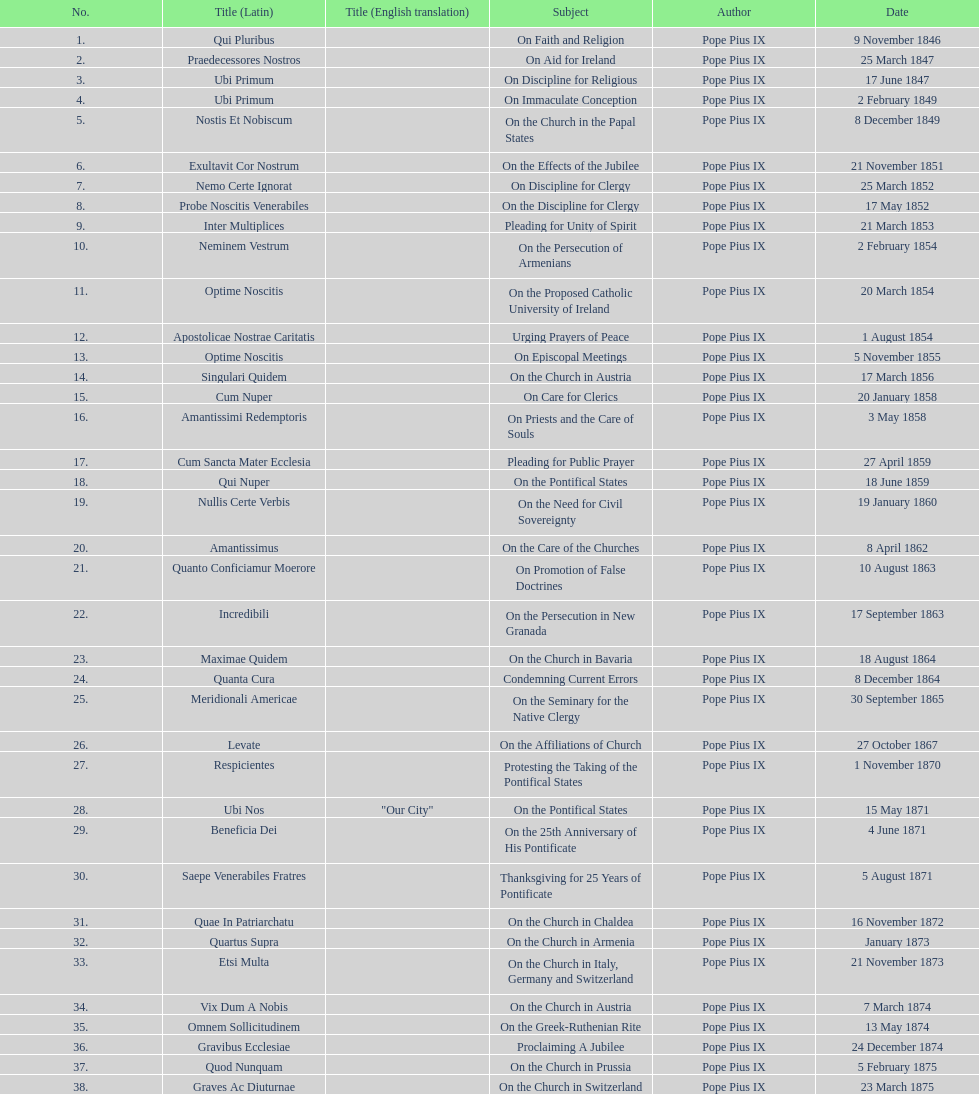What is the previous subject after on the effects of the jubilee? On the Church in the Papal States. Parse the full table. {'header': ['No.', 'Title (Latin)', 'Title (English translation)', 'Subject', 'Author', 'Date'], 'rows': [['1.', 'Qui Pluribus', '', 'On Faith and Religion', 'Pope Pius IX', '9 November 1846'], ['2.', 'Praedecessores Nostros', '', 'On Aid for Ireland', 'Pope Pius IX', '25 March 1847'], ['3.', 'Ubi Primum', '', 'On Discipline for Religious', 'Pope Pius IX', '17 June 1847'], ['4.', 'Ubi Primum', '', 'On Immaculate Conception', 'Pope Pius IX', '2 February 1849'], ['5.', 'Nostis Et Nobiscum', '', 'On the Church in the Papal States', 'Pope Pius IX', '8 December 1849'], ['6.', 'Exultavit Cor Nostrum', '', 'On the Effects of the Jubilee', 'Pope Pius IX', '21 November 1851'], ['7.', 'Nemo Certe Ignorat', '', 'On Discipline for Clergy', 'Pope Pius IX', '25 March 1852'], ['8.', 'Probe Noscitis Venerabiles', '', 'On the Discipline for Clergy', 'Pope Pius IX', '17 May 1852'], ['9.', 'Inter Multiplices', '', 'Pleading for Unity of Spirit', 'Pope Pius IX', '21 March 1853'], ['10.', 'Neminem Vestrum', '', 'On the Persecution of Armenians', 'Pope Pius IX', '2 February 1854'], ['11.', 'Optime Noscitis', '', 'On the Proposed Catholic University of Ireland', 'Pope Pius IX', '20 March 1854'], ['12.', 'Apostolicae Nostrae Caritatis', '', 'Urging Prayers of Peace', 'Pope Pius IX', '1 August 1854'], ['13.', 'Optime Noscitis', '', 'On Episcopal Meetings', 'Pope Pius IX', '5 November 1855'], ['14.', 'Singulari Quidem', '', 'On the Church in Austria', 'Pope Pius IX', '17 March 1856'], ['15.', 'Cum Nuper', '', 'On Care for Clerics', 'Pope Pius IX', '20 January 1858'], ['16.', 'Amantissimi Redemptoris', '', 'On Priests and the Care of Souls', 'Pope Pius IX', '3 May 1858'], ['17.', 'Cum Sancta Mater Ecclesia', '', 'Pleading for Public Prayer', 'Pope Pius IX', '27 April 1859'], ['18.', 'Qui Nuper', '', 'On the Pontifical States', 'Pope Pius IX', '18 June 1859'], ['19.', 'Nullis Certe Verbis', '', 'On the Need for Civil Sovereignty', 'Pope Pius IX', '19 January 1860'], ['20.', 'Amantissimus', '', 'On the Care of the Churches', 'Pope Pius IX', '8 April 1862'], ['21.', 'Quanto Conficiamur Moerore', '', 'On Promotion of False Doctrines', 'Pope Pius IX', '10 August 1863'], ['22.', 'Incredibili', '', 'On the Persecution in New Granada', 'Pope Pius IX', '17 September 1863'], ['23.', 'Maximae Quidem', '', 'On the Church in Bavaria', 'Pope Pius IX', '18 August 1864'], ['24.', 'Quanta Cura', '', 'Condemning Current Errors', 'Pope Pius IX', '8 December 1864'], ['25.', 'Meridionali Americae', '', 'On the Seminary for the Native Clergy', 'Pope Pius IX', '30 September 1865'], ['26.', 'Levate', '', 'On the Affiliations of Church', 'Pope Pius IX', '27 October 1867'], ['27.', 'Respicientes', '', 'Protesting the Taking of the Pontifical States', 'Pope Pius IX', '1 November 1870'], ['28.', 'Ubi Nos', '"Our City"', 'On the Pontifical States', 'Pope Pius IX', '15 May 1871'], ['29.', 'Beneficia Dei', '', 'On the 25th Anniversary of His Pontificate', 'Pope Pius IX', '4 June 1871'], ['30.', 'Saepe Venerabiles Fratres', '', 'Thanksgiving for 25 Years of Pontificate', 'Pope Pius IX', '5 August 1871'], ['31.', 'Quae In Patriarchatu', '', 'On the Church in Chaldea', 'Pope Pius IX', '16 November 1872'], ['32.', 'Quartus Supra', '', 'On the Church in Armenia', 'Pope Pius IX', 'January 1873'], ['33.', 'Etsi Multa', '', 'On the Church in Italy, Germany and Switzerland', 'Pope Pius IX', '21 November 1873'], ['34.', 'Vix Dum A Nobis', '', 'On the Church in Austria', 'Pope Pius IX', '7 March 1874'], ['35.', 'Omnem Sollicitudinem', '', 'On the Greek-Ruthenian Rite', 'Pope Pius IX', '13 May 1874'], ['36.', 'Gravibus Ecclesiae', '', 'Proclaiming A Jubilee', 'Pope Pius IX', '24 December 1874'], ['37.', 'Quod Nunquam', '', 'On the Church in Prussia', 'Pope Pius IX', '5 February 1875'], ['38.', 'Graves Ac Diuturnae', '', 'On the Church in Switzerland', 'Pope Pius IX', '23 March 1875']]} 